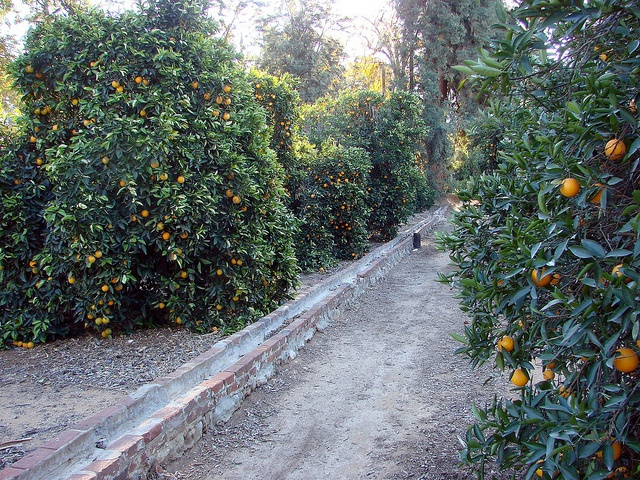Describe the objects in this image and their specific colors. I can see orange in lightgreen, black, gray, teal, and darkgreen tones, orange in lightgreen, olive, and maroon tones, orange in lightgreen, maroon, olive, tan, and black tones, orange in lightgreen and orange tones, and orange in lightgreen, maroon, brown, and black tones in this image. 